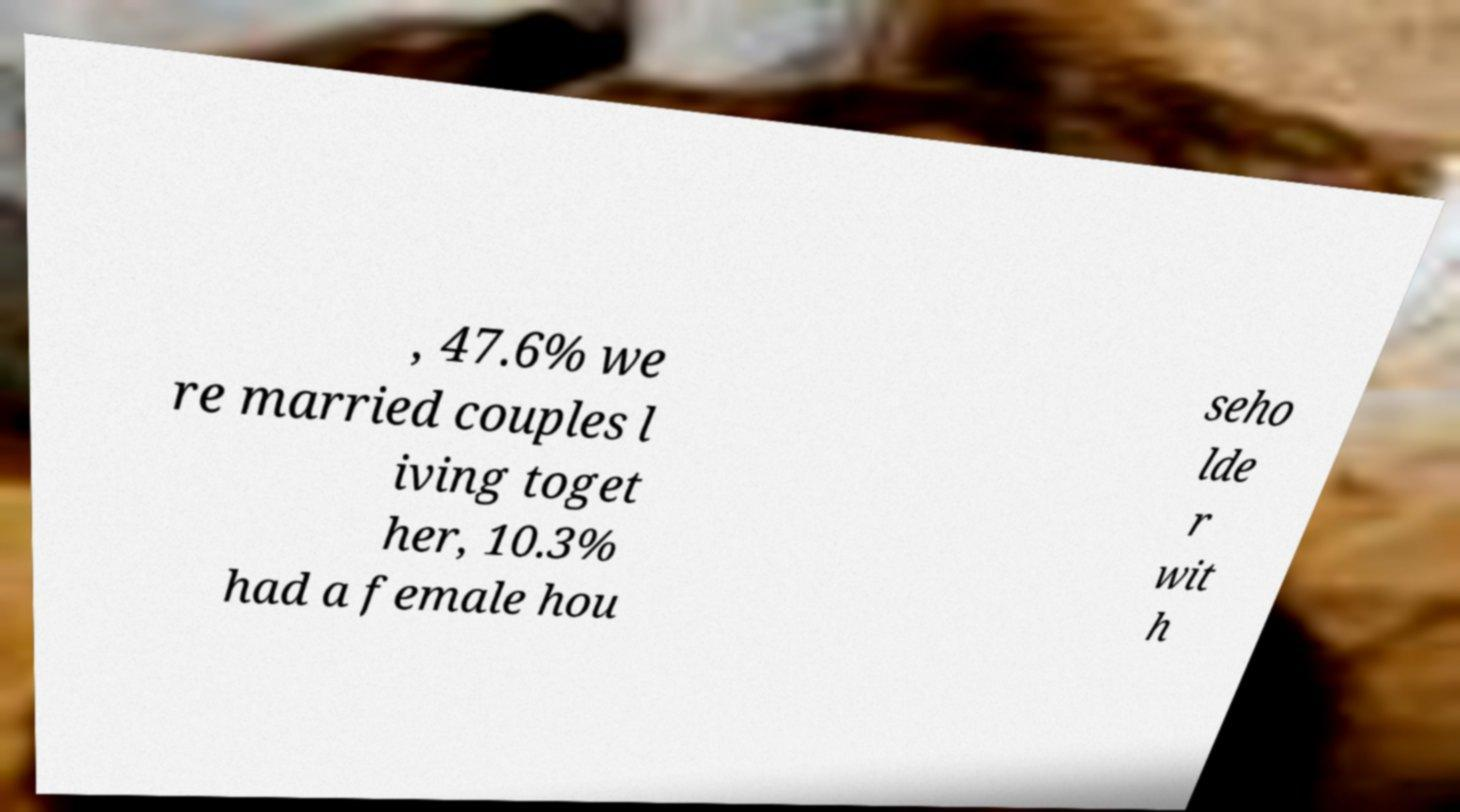Please read and relay the text visible in this image. What does it say? , 47.6% we re married couples l iving toget her, 10.3% had a female hou seho lde r wit h 